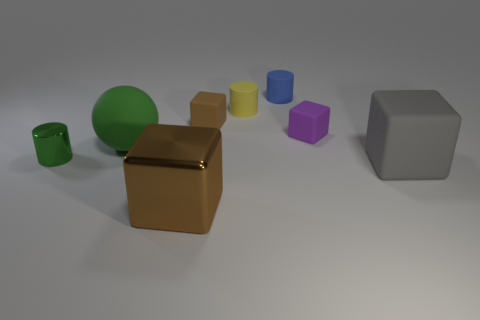Add 1 big metallic blocks. How many objects exist? 9 Subtract all green cubes. Subtract all gray balls. How many cubes are left? 4 Subtract all spheres. How many objects are left? 7 Add 1 matte objects. How many matte objects exist? 7 Subtract 0 red cubes. How many objects are left? 8 Subtract all large green metal objects. Subtract all big rubber spheres. How many objects are left? 7 Add 6 large gray matte things. How many large gray matte things are left? 7 